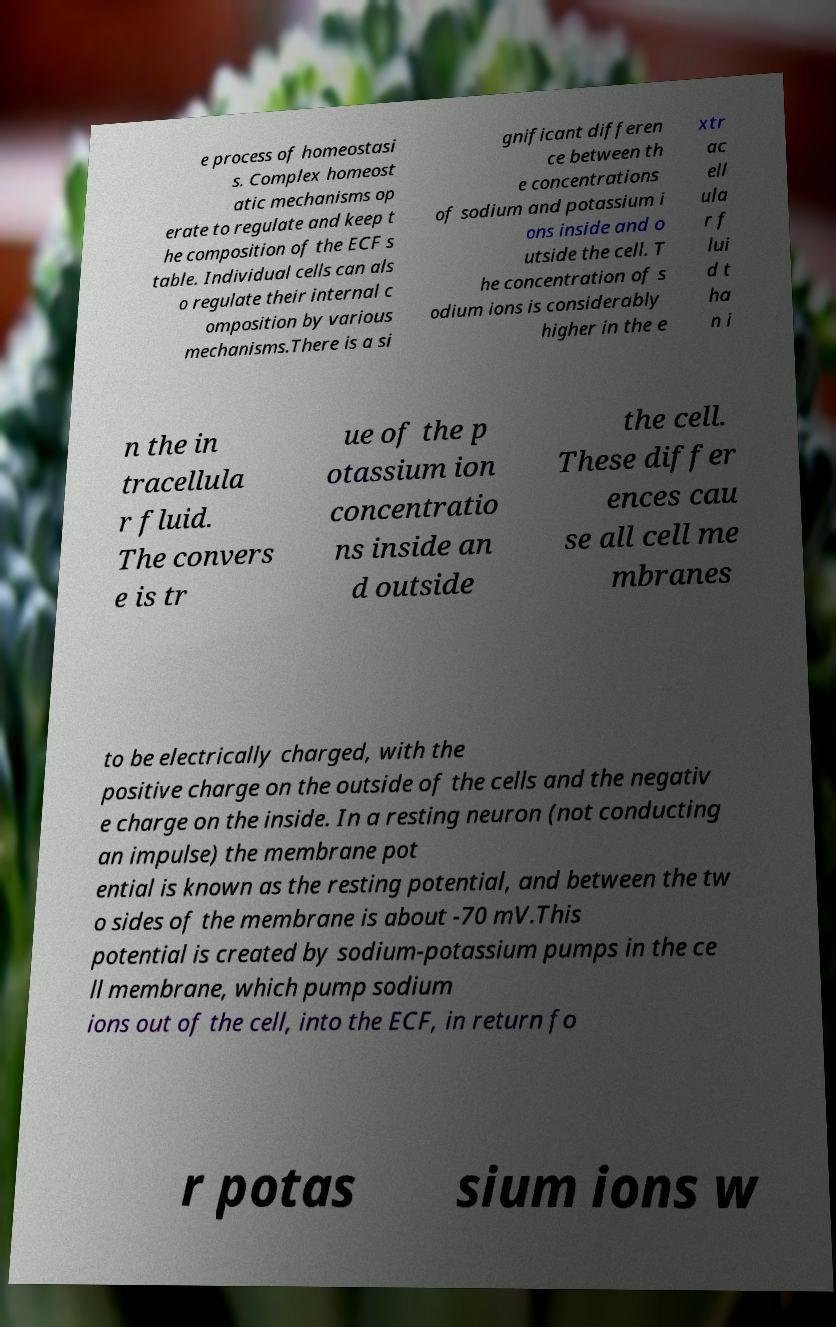Could you assist in decoding the text presented in this image and type it out clearly? e process of homeostasi s. Complex homeost atic mechanisms op erate to regulate and keep t he composition of the ECF s table. Individual cells can als o regulate their internal c omposition by various mechanisms.There is a si gnificant differen ce between th e concentrations of sodium and potassium i ons inside and o utside the cell. T he concentration of s odium ions is considerably higher in the e xtr ac ell ula r f lui d t ha n i n the in tracellula r fluid. The convers e is tr ue of the p otassium ion concentratio ns inside an d outside the cell. These differ ences cau se all cell me mbranes to be electrically charged, with the positive charge on the outside of the cells and the negativ e charge on the inside. In a resting neuron (not conducting an impulse) the membrane pot ential is known as the resting potential, and between the tw o sides of the membrane is about -70 mV.This potential is created by sodium-potassium pumps in the ce ll membrane, which pump sodium ions out of the cell, into the ECF, in return fo r potas sium ions w 